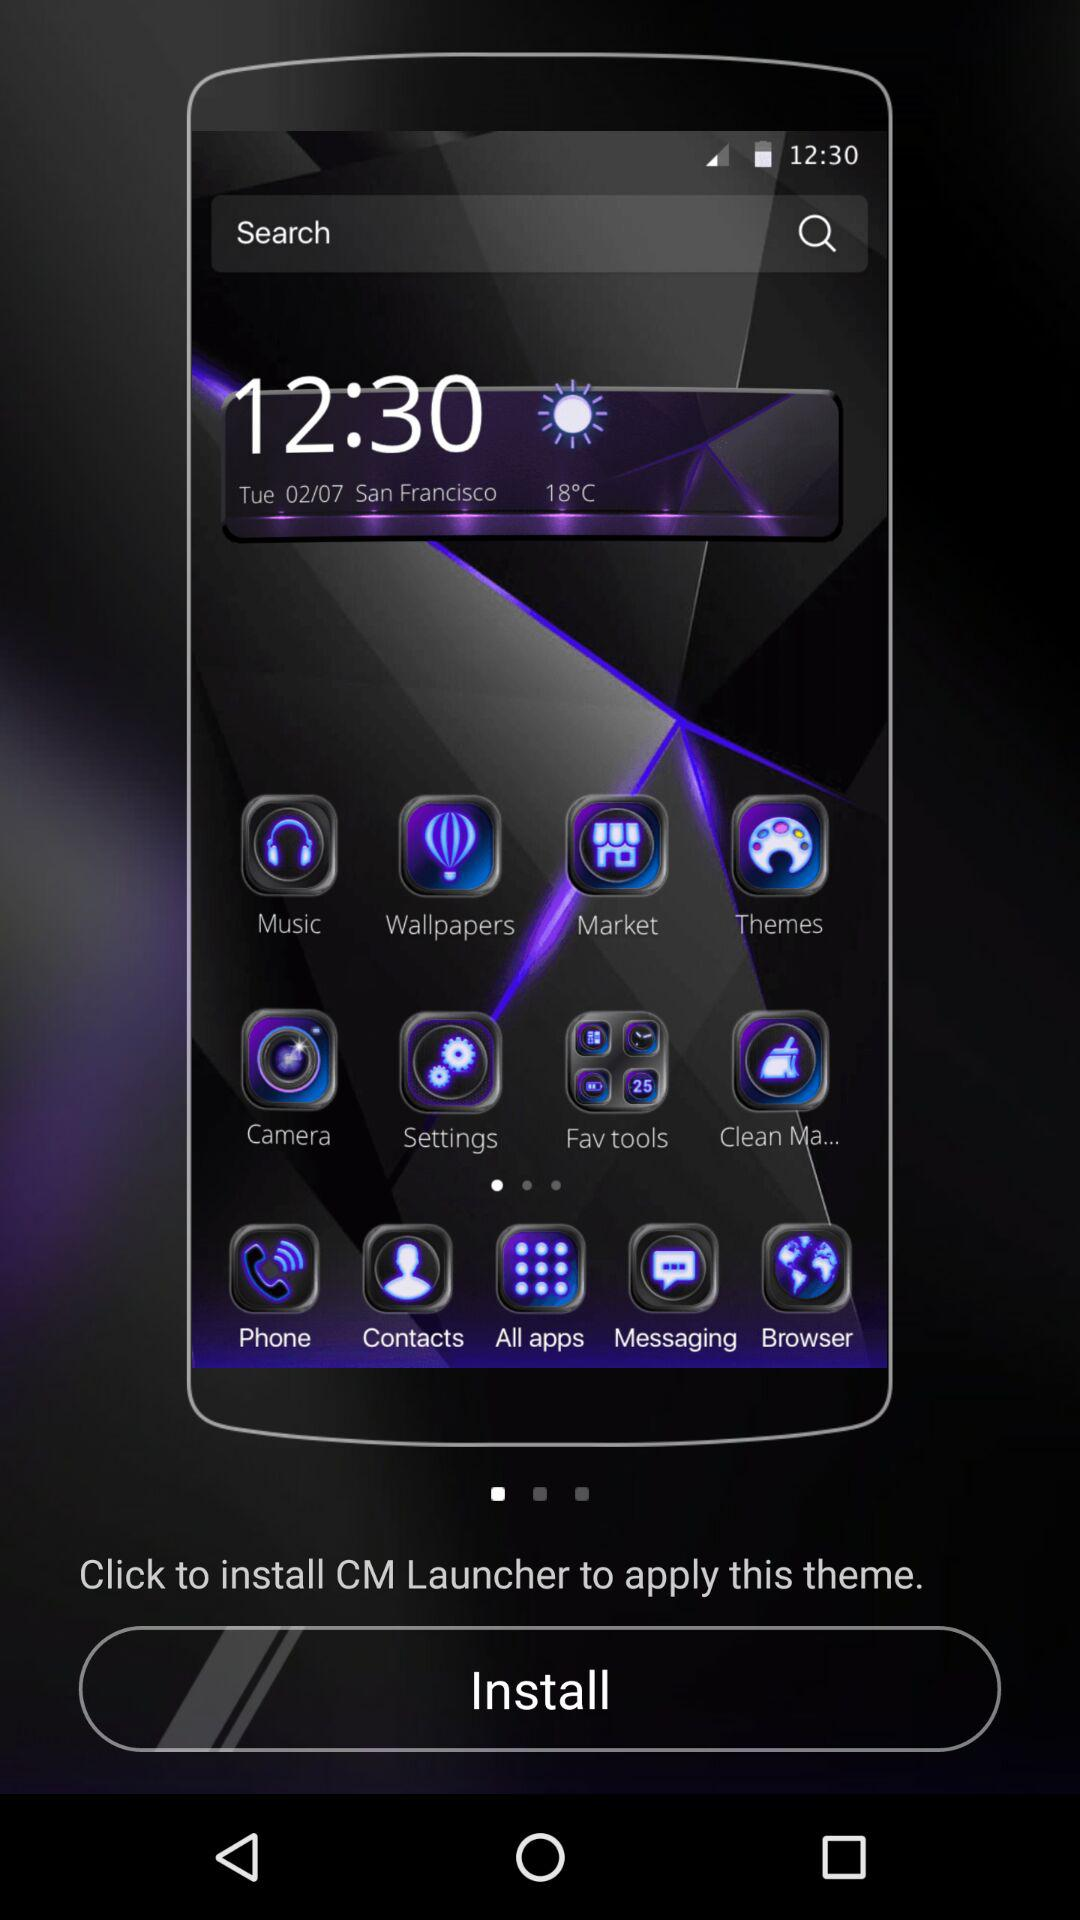What is the application name? The application name is "CM Launcher". 